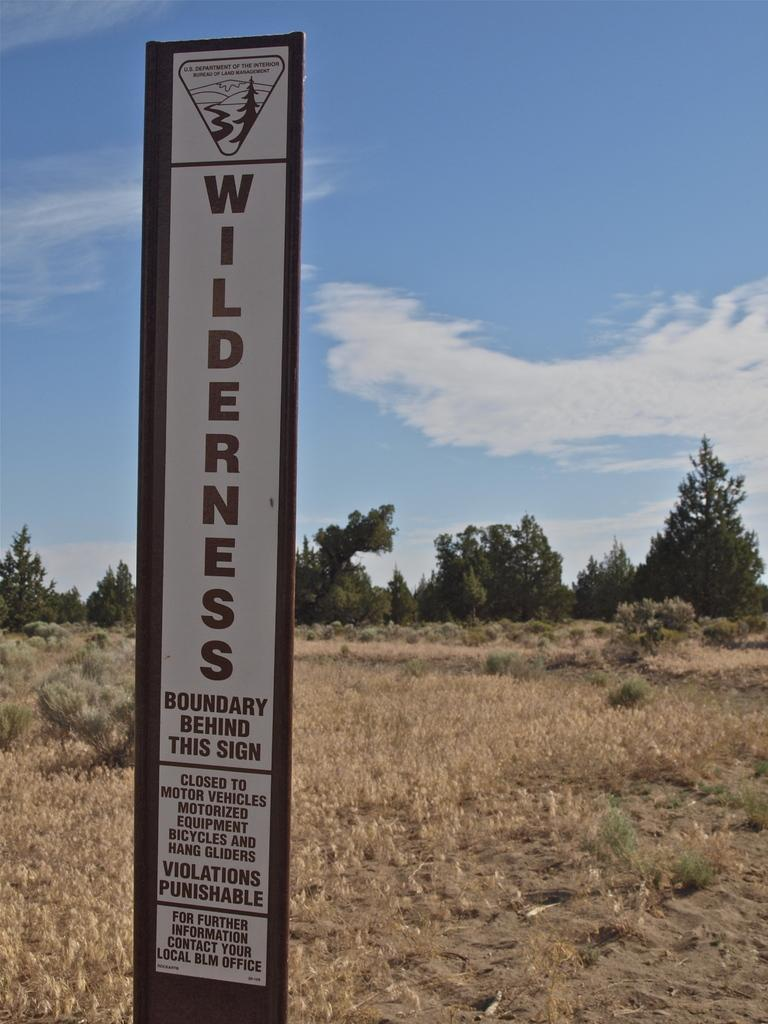What is written on the board in the image? The facts do not specify the text on the board, so we cannot answer that question definitively. What type of vegetation can be seen in the image? There is dried grass and trees visible in the image. What is visible in the sky in the image? Clouds are visible in the sky in the image. Can you see a lake in the image? There is no mention of a lake in the image, so we cannot confirm its presence. Is there a letter being delivered in the image? There is no mention of a letter or delivery in the image, so we cannot confirm its presence. 